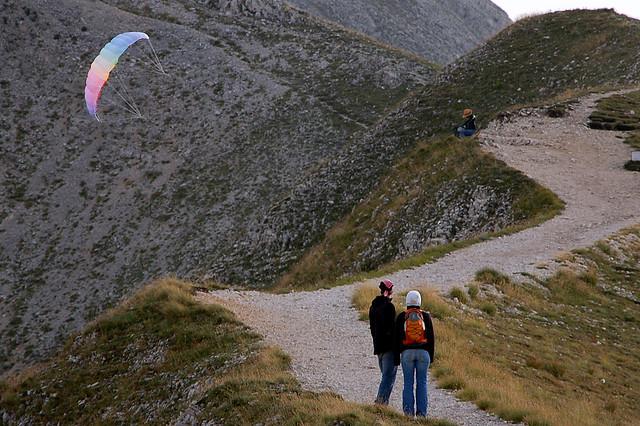Is anybody in the photo facing the camera?
Give a very brief answer. No. Where is this picture taken?
Write a very short answer. Mountains. What are these people doing?
Answer briefly. Hiking. 